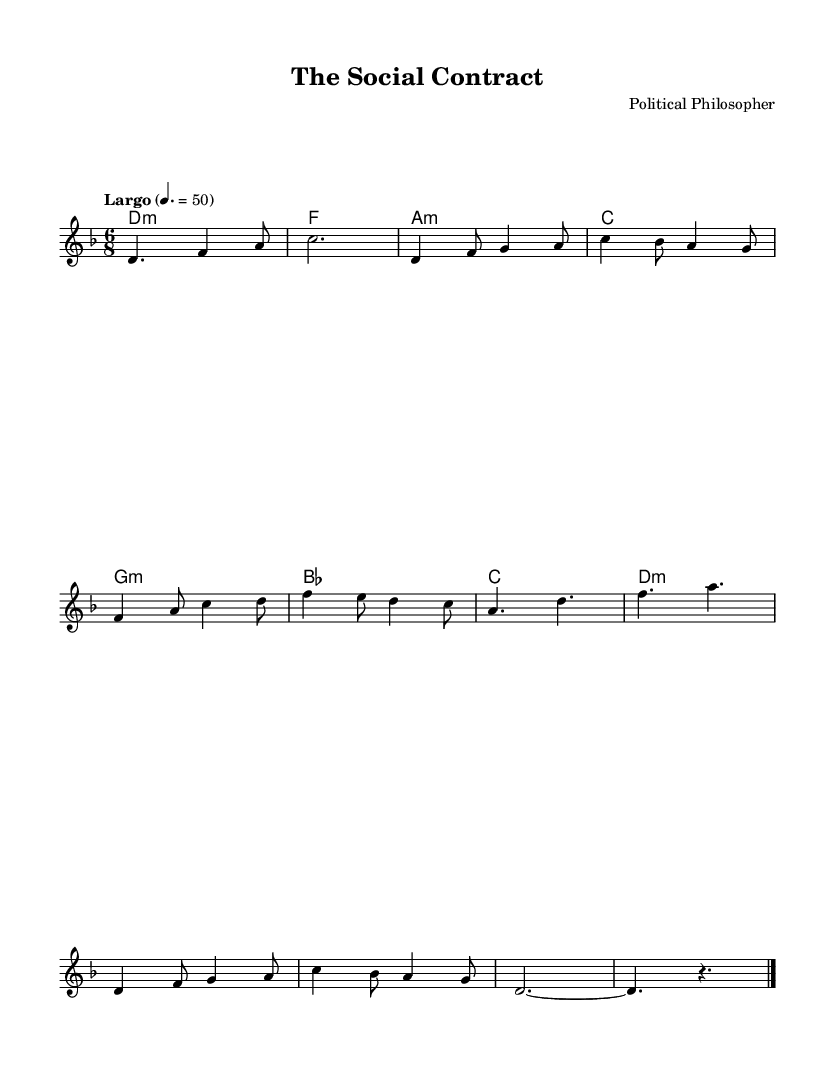What is the key signature of this music? The key signature is indicated by the relevant symbols placed at the beginning of the staff. In this case, it shows two flats, which defines the key signature as D minor.
Answer: D minor What is the time signature of this music? The time signature is shown right after the key signature at the beginning of the music. Here, it displays 6/8, indicating there are six eighth notes in each measure.
Answer: 6/8 What is the tempo marking in this piece? The tempo marking is written above the staff, specifically stating "Largo" followed by a metronome value of 50, which indicates the speed of the music.
Answer: Largo, 50 How many main themes are introduced in this composition? By analyzing the music, the two distinct themes labeled as Theme A and Theme B can be identified, making a total of two prominent themes presented throughout the piece.
Answer: 2 What type of harmony is primarily used in this piece? The chord symbols present in the sheet indicate that the harmony employs minor chords predominantly, as seen from the D minor and related chords listed, thus forming an ambient texture.
Answer: Minor chords Which musical section is identified as the interlude? The interlude section is labeled in the music and shows a simplified pattern that contrasts the themes and flows between the different ideas in the piece. It is specifically marked as the interlude.
Answer: Interlude 